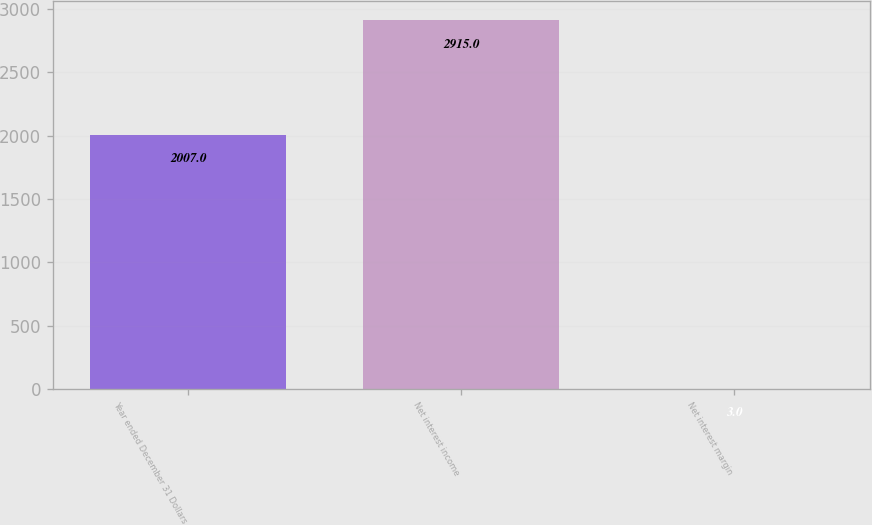<chart> <loc_0><loc_0><loc_500><loc_500><bar_chart><fcel>Year ended December 31 Dollars<fcel>Net interest income<fcel>Net interest margin<nl><fcel>2007<fcel>2915<fcel>3<nl></chart> 